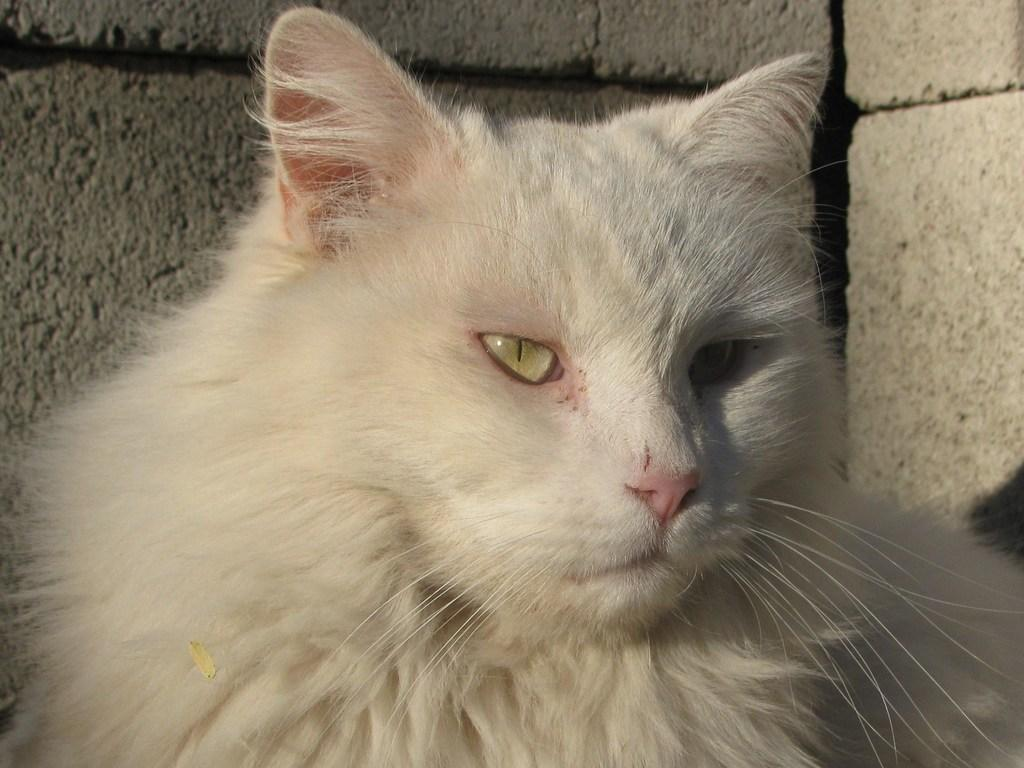What type of animal is in the image? There is a white cat in the image. What can be seen behind the white cat? There are bricks visible behind the white cat. What type of agreement is being discussed by the white cat in the image? There is no indication in the image that the white cat is discussing any agreement, as cats do not engage in human-like discussions. 